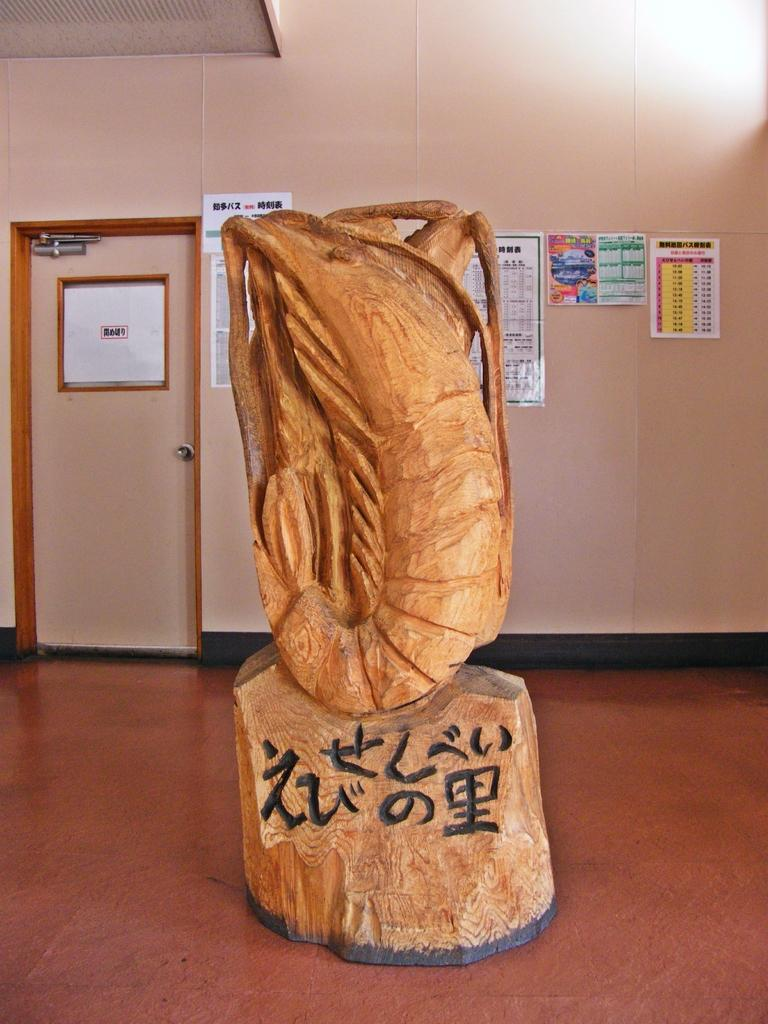<image>
Provide a brief description of the given image. A tan carved piece sitting on a base with the markings "ZU" and some Chinese characters. 